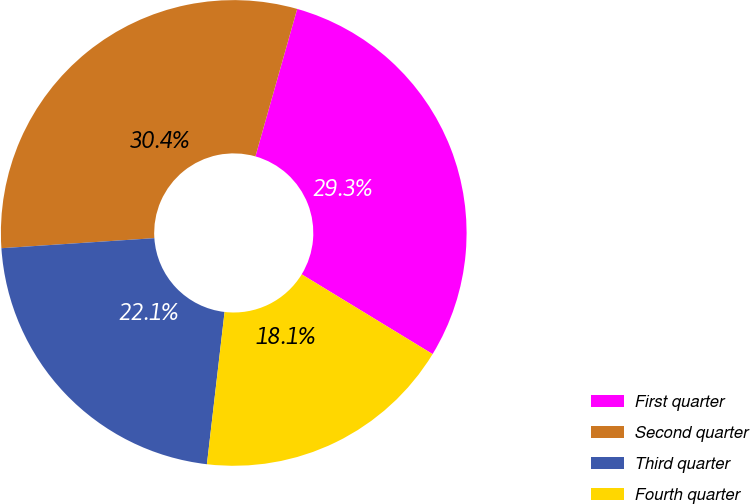Convert chart. <chart><loc_0><loc_0><loc_500><loc_500><pie_chart><fcel>First quarter<fcel>Second quarter<fcel>Third quarter<fcel>Fourth quarter<nl><fcel>29.32%<fcel>30.44%<fcel>22.12%<fcel>18.13%<nl></chart> 